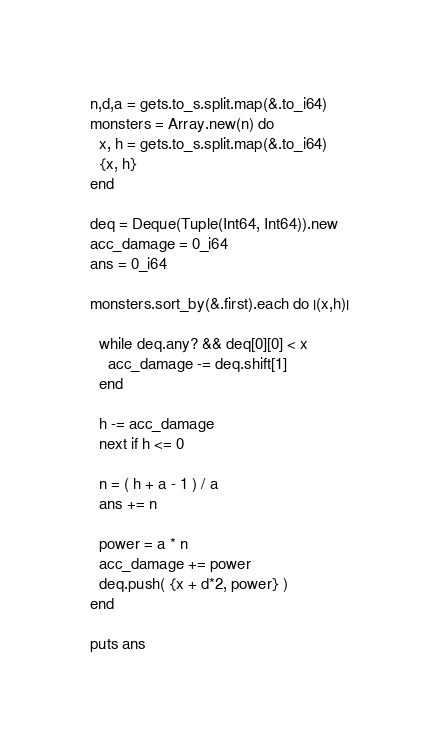Convert code to text. <code><loc_0><loc_0><loc_500><loc_500><_Crystal_>n,d,a = gets.to_s.split.map(&.to_i64)
monsters = Array.new(n) do
  x, h = gets.to_s.split.map(&.to_i64)
  {x, h}
end

deq = Deque(Tuple(Int64, Int64)).new
acc_damage = 0_i64
ans = 0_i64

monsters.sort_by(&.first).each do |(x,h)|
  
  while deq.any? && deq[0][0] < x
    acc_damage -= deq.shift[1]
  end
  
  h -= acc_damage
  next if h <= 0
  
  n = ( h + a - 1 ) / a
  ans += n
  
  power = a * n
  acc_damage += power
  deq.push( {x + d*2, power} )
end

puts ans</code> 